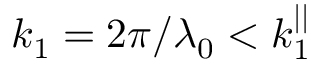Convert formula to latex. <formula><loc_0><loc_0><loc_500><loc_500>k _ { 1 } = 2 \pi / \lambda _ { 0 } < k _ { 1 } ^ { | | }</formula> 